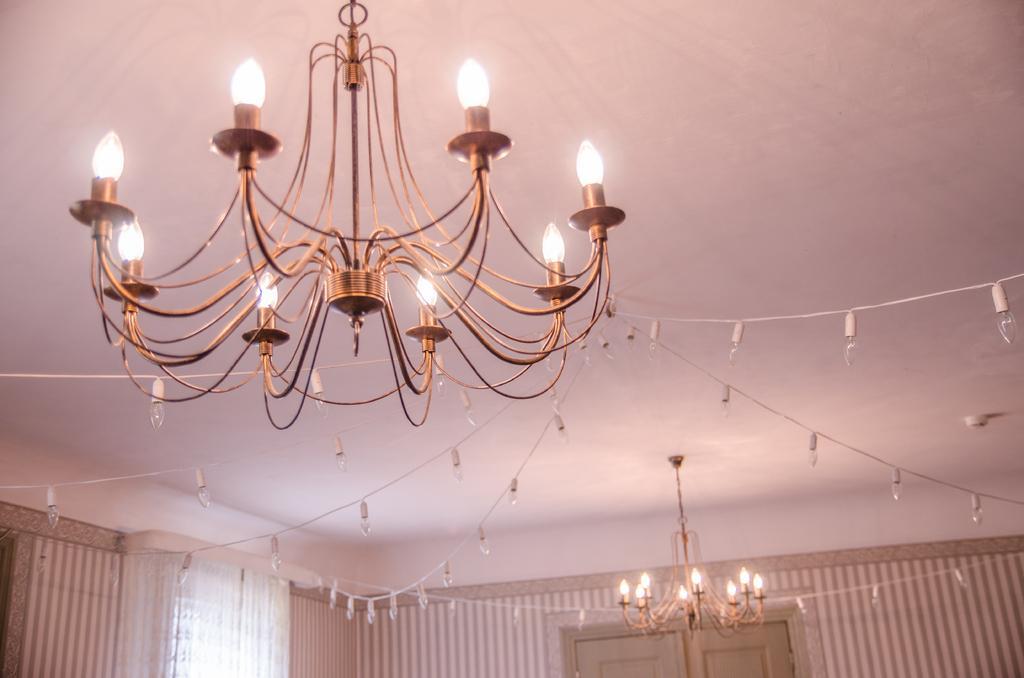How would you summarize this image in a sentence or two? In this image I can see two chandeliers and string lights decorated on the ceiling. Here I can see a wall and other objects. 